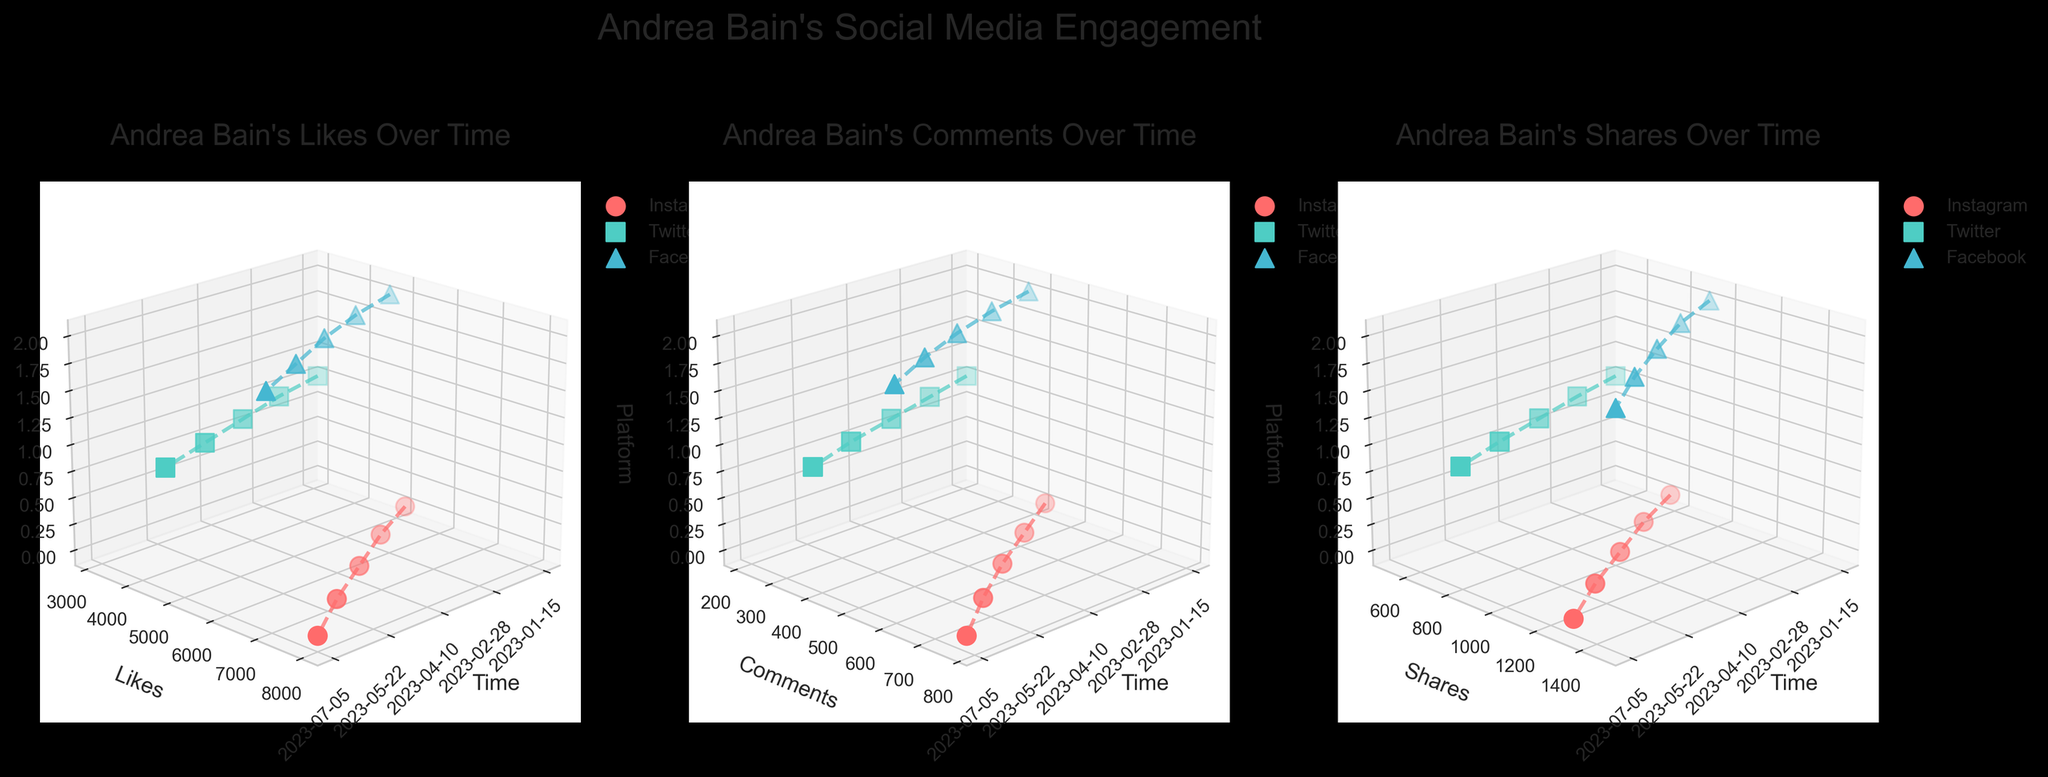Which metric has the highest value for Instagram on July 5? On July 5, in the plot for Instagram, the metric "Likes" is the highest value, reaching 8000. The other metrics "Comments" and "Shares" are 780 and 1300 respectively.
Answer: Likes What is the main title of the figure? The main title is displayed at the top of the figure, and it reads "Andrea Bain's Social Media Engagement."
Answer: Andrea Bain's Social Media Engagement How many different time points are shown in the figure? By counting the unique dates on the x-axis, there are five time points shown: 2023-01-15, 2023-02-28, 2023-04-10, 2023-05-22, and 2023-07-05.
Answer: 5 Which platform had the lowest number of comments on April 10? On April 10, the plot shows that Twitter had the lowest number of comments with a value of 290, which is lower compared to Instagram (590) and Facebook (470).
Answer: Twitter Which date saw the highest number of likes for Facebook? By comparing the "Likes" values for Facebook across the dates, July 5 had the highest number of likes at 6900.
Answer: July 5 What is the average number of shares for Andrea Bain's posts on Instagram? Summing the shares for Instagram across all dates: 780 + 890 + 1020 + 1150 + 1300 = 5140. There are 5 dates, so the average is 5140 / 5 = 1028.
Answer: 1028 Which platform shows the steepest increase in the number of likes over time? Analyzing the trend lines for "Likes" in the subplots, Instagram shows the steepest increase, starting from 5200 on January 15 and rising sharply to 8000 on July 5.
Answer: Instagram On which date did Twitter have the greatest increase in shares compared to the previous date? Comparing the shares for Twitter, the greatest increase occurs between May 22 (720 shares) and July 5 (800 shares) with an increase of 80 shares.
Answer: July 5 What is the trend in the number of comments on Facebook over the observed dates? From the plot for comments on Facebook, the trend shows a consistent increase from 380 on January 15 to 600 on July 5.
Answer: Increasing How do the number of shares on Instagram compare to those on Facebook on May 22? On May 22, Instagram has 1150 shares while Facebook has 1320 shares. Therefore, Facebook has more shares than Instagram on this date.
Answer: Facebook has more shares 